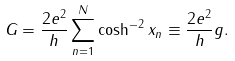Convert formula to latex. <formula><loc_0><loc_0><loc_500><loc_500>G = \frac { 2 e ^ { 2 } } { h } \sum _ { n = 1 } ^ { N } \cosh ^ { - 2 } x _ { n } \equiv \frac { 2 e ^ { 2 } } { h } g .</formula> 